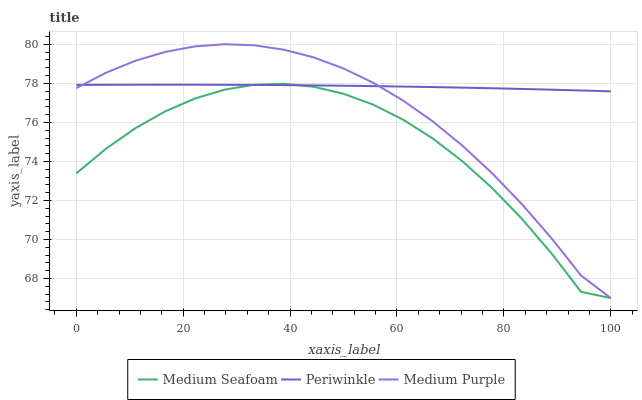Does Medium Seafoam have the minimum area under the curve?
Answer yes or no. Yes. Does Periwinkle have the maximum area under the curve?
Answer yes or no. Yes. Does Periwinkle have the minimum area under the curve?
Answer yes or no. No. Does Medium Seafoam have the maximum area under the curve?
Answer yes or no. No. Is Periwinkle the smoothest?
Answer yes or no. Yes. Is Medium Seafoam the roughest?
Answer yes or no. Yes. Is Medium Seafoam the smoothest?
Answer yes or no. No. Is Periwinkle the roughest?
Answer yes or no. No. Does Periwinkle have the lowest value?
Answer yes or no. No. Does Medium Seafoam have the highest value?
Answer yes or no. No. 